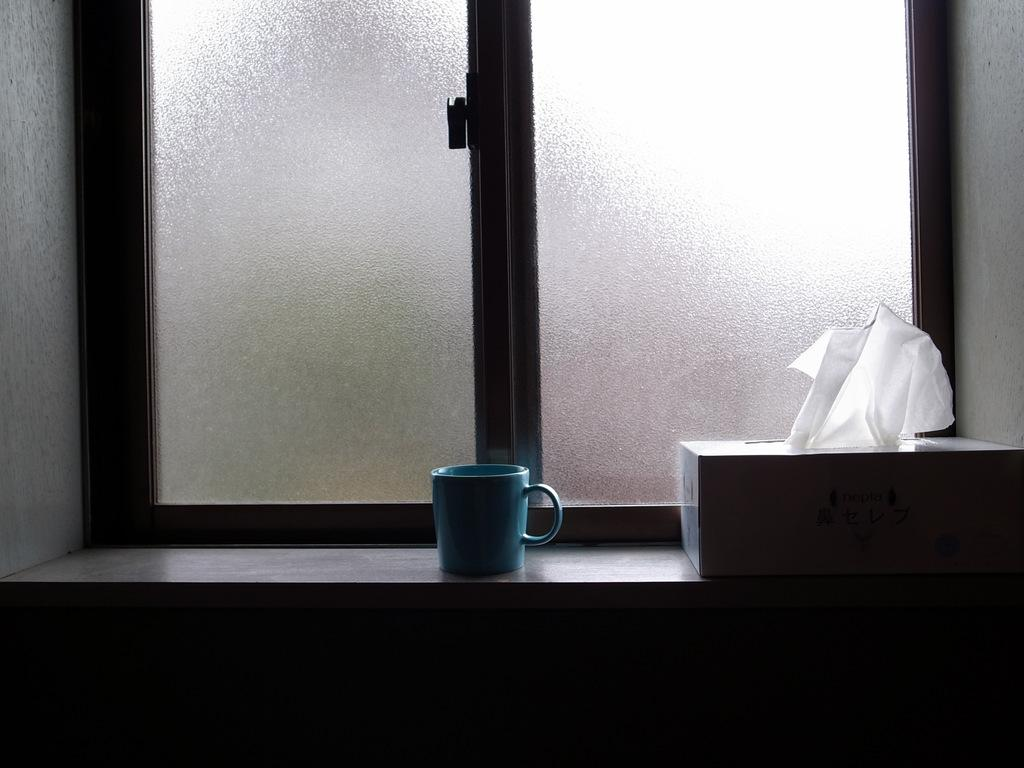What color is the cup in the image? The cup in the image is blue. What is inside the box that is visible in the image? There is a box containing white tissues in the image. Can you describe the window in the image? There is a window visible in the image. What type of rail can be seen in the image? There is no rail present in the image. What color are the teeth of the person in the image? There is no person or teeth visible in the image. 